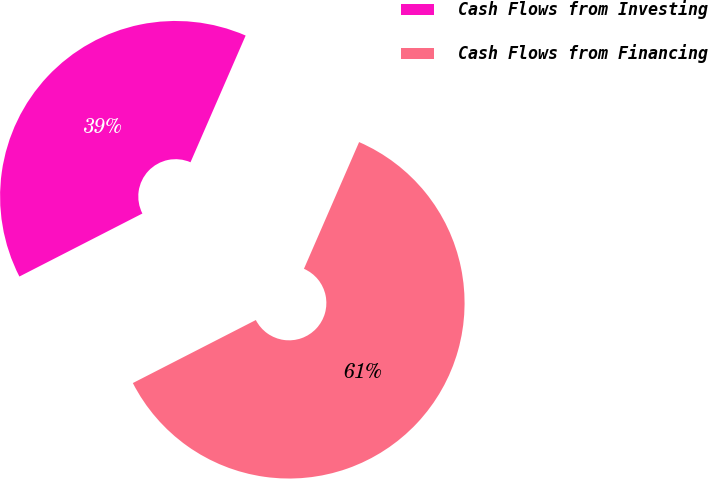<chart> <loc_0><loc_0><loc_500><loc_500><pie_chart><fcel>Cash Flows from Investing<fcel>Cash Flows from Financing<nl><fcel>39.07%<fcel>60.93%<nl></chart> 